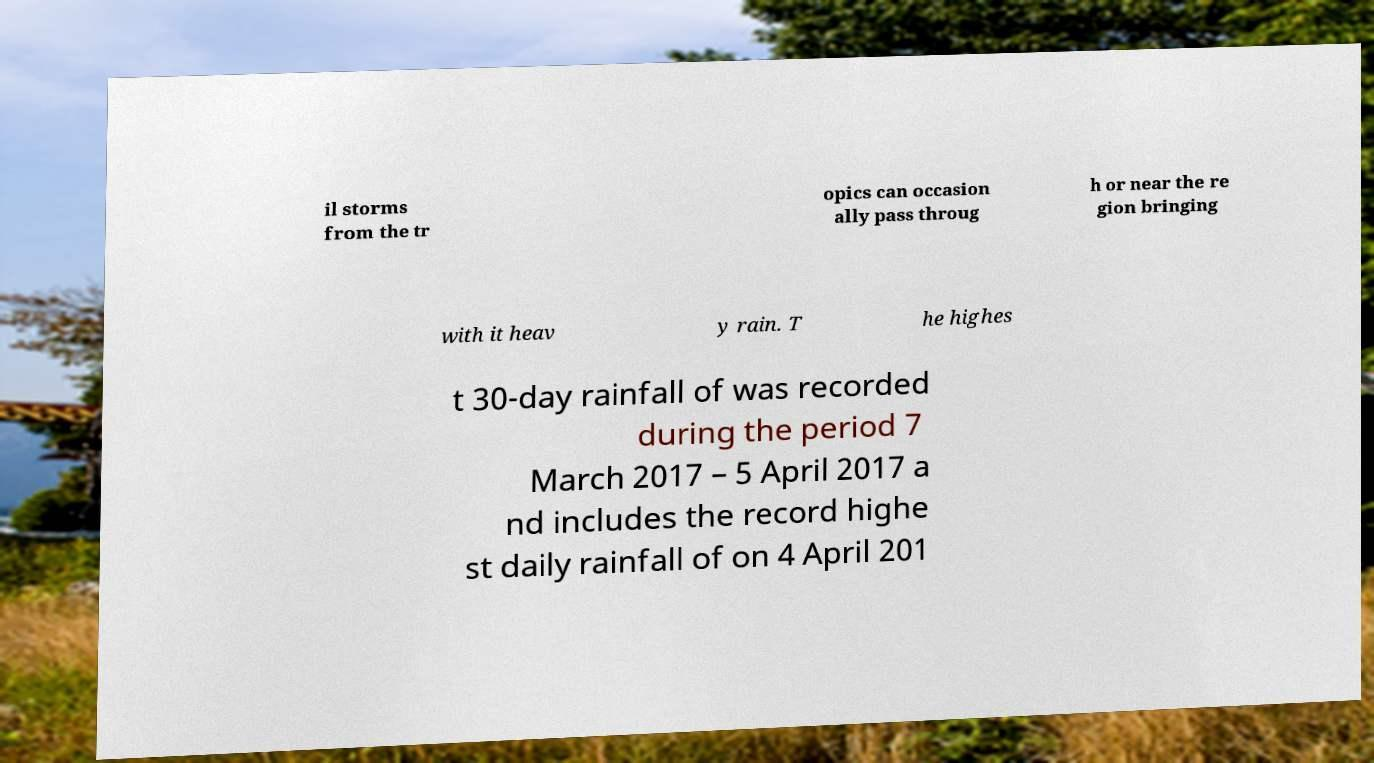I need the written content from this picture converted into text. Can you do that? il storms from the tr opics can occasion ally pass throug h or near the re gion bringing with it heav y rain. T he highes t 30-day rainfall of was recorded during the period 7 March 2017 – 5 April 2017 a nd includes the record highe st daily rainfall of on 4 April 201 